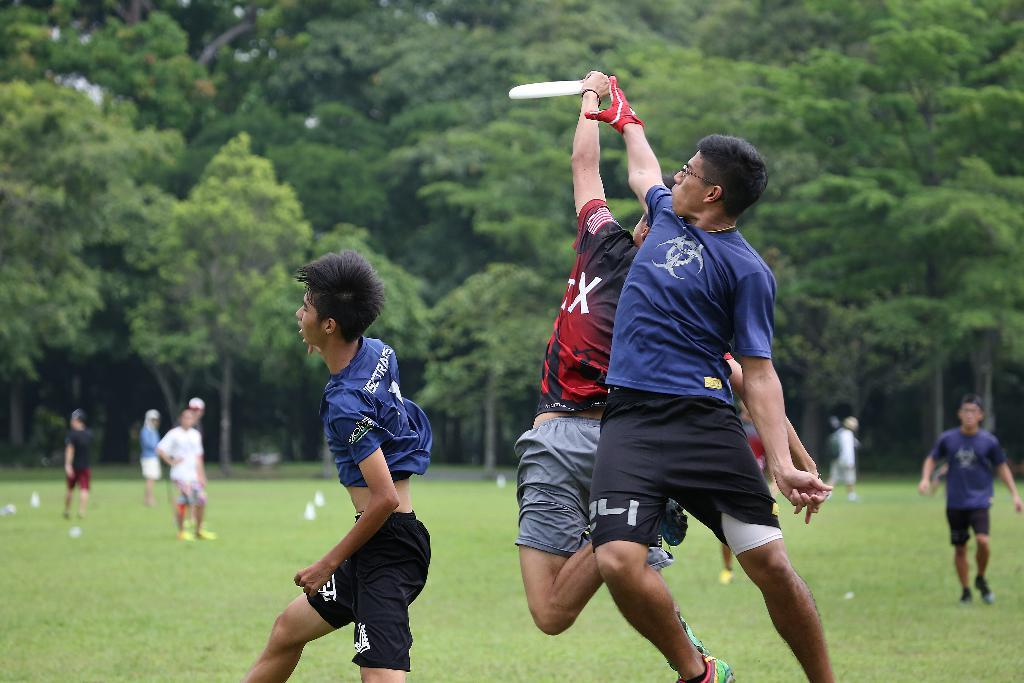<image>
Share a concise interpretation of the image provided. A man jumping wearing a blue shirt and the number 24 on his shorts 